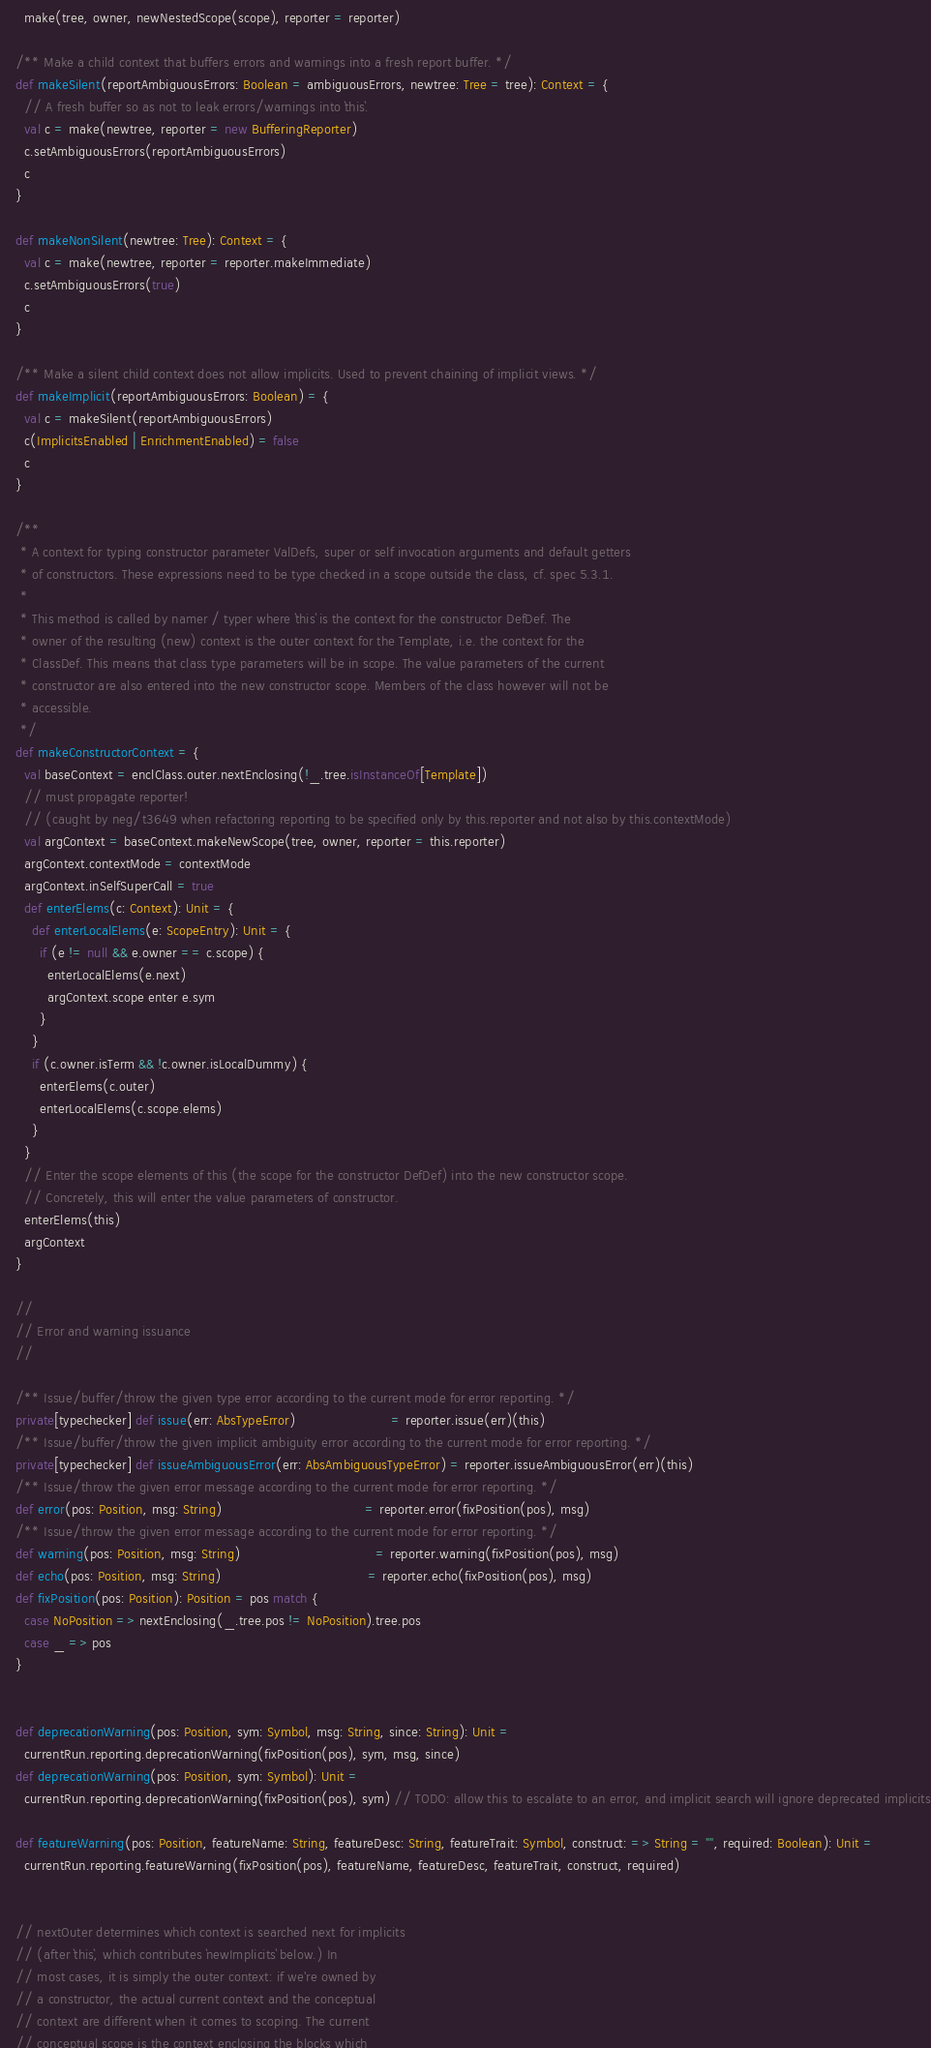<code> <loc_0><loc_0><loc_500><loc_500><_Scala_>      make(tree, owner, newNestedScope(scope), reporter = reporter)

    /** Make a child context that buffers errors and warnings into a fresh report buffer. */
    def makeSilent(reportAmbiguousErrors: Boolean = ambiguousErrors, newtree: Tree = tree): Context = {
      // A fresh buffer so as not to leak errors/warnings into `this`.
      val c = make(newtree, reporter = new BufferingReporter)
      c.setAmbiguousErrors(reportAmbiguousErrors)
      c
    }

    def makeNonSilent(newtree: Tree): Context = {
      val c = make(newtree, reporter = reporter.makeImmediate)
      c.setAmbiguousErrors(true)
      c
    }

    /** Make a silent child context does not allow implicits. Used to prevent chaining of implicit views. */
    def makeImplicit(reportAmbiguousErrors: Boolean) = {
      val c = makeSilent(reportAmbiguousErrors)
      c(ImplicitsEnabled | EnrichmentEnabled) = false
      c
    }

    /**
     * A context for typing constructor parameter ValDefs, super or self invocation arguments and default getters
     * of constructors. These expressions need to be type checked in a scope outside the class, cf. spec 5.3.1.
     *
     * This method is called by namer / typer where `this` is the context for the constructor DefDef. The
     * owner of the resulting (new) context is the outer context for the Template, i.e. the context for the
     * ClassDef. This means that class type parameters will be in scope. The value parameters of the current
     * constructor are also entered into the new constructor scope. Members of the class however will not be
     * accessible.
     */
    def makeConstructorContext = {
      val baseContext = enclClass.outer.nextEnclosing(!_.tree.isInstanceOf[Template])
      // must propagate reporter!
      // (caught by neg/t3649 when refactoring reporting to be specified only by this.reporter and not also by this.contextMode)
      val argContext = baseContext.makeNewScope(tree, owner, reporter = this.reporter)
      argContext.contextMode = contextMode
      argContext.inSelfSuperCall = true
      def enterElems(c: Context): Unit = {
        def enterLocalElems(e: ScopeEntry): Unit = {
          if (e != null && e.owner == c.scope) {
            enterLocalElems(e.next)
            argContext.scope enter e.sym
          }
        }
        if (c.owner.isTerm && !c.owner.isLocalDummy) {
          enterElems(c.outer)
          enterLocalElems(c.scope.elems)
        }
      }
      // Enter the scope elements of this (the scope for the constructor DefDef) into the new constructor scope.
      // Concretely, this will enter the value parameters of constructor.
      enterElems(this)
      argContext
    }

    //
    // Error and warning issuance
    //

    /** Issue/buffer/throw the given type error according to the current mode for error reporting. */
    private[typechecker] def issue(err: AbsTypeError)                        = reporter.issue(err)(this)
    /** Issue/buffer/throw the given implicit ambiguity error according to the current mode for error reporting. */
    private[typechecker] def issueAmbiguousError(err: AbsAmbiguousTypeError) = reporter.issueAmbiguousError(err)(this)
    /** Issue/throw the given error message according to the current mode for error reporting. */
    def error(pos: Position, msg: String)                                    = reporter.error(fixPosition(pos), msg)
    /** Issue/throw the given error message according to the current mode for error reporting. */
    def warning(pos: Position, msg: String)                                  = reporter.warning(fixPosition(pos), msg)
    def echo(pos: Position, msg: String)                                     = reporter.echo(fixPosition(pos), msg)
    def fixPosition(pos: Position): Position = pos match {
      case NoPosition => nextEnclosing(_.tree.pos != NoPosition).tree.pos
      case _ => pos
    }


    def deprecationWarning(pos: Position, sym: Symbol, msg: String, since: String): Unit =
      currentRun.reporting.deprecationWarning(fixPosition(pos), sym, msg, since)
    def deprecationWarning(pos: Position, sym: Symbol): Unit =
      currentRun.reporting.deprecationWarning(fixPosition(pos), sym) // TODO: allow this to escalate to an error, and implicit search will ignore deprecated implicits

    def featureWarning(pos: Position, featureName: String, featureDesc: String, featureTrait: Symbol, construct: => String = "", required: Boolean): Unit =
      currentRun.reporting.featureWarning(fixPosition(pos), featureName, featureDesc, featureTrait, construct, required)


    // nextOuter determines which context is searched next for implicits
    // (after `this`, which contributes `newImplicits` below.) In
    // most cases, it is simply the outer context: if we're owned by
    // a constructor, the actual current context and the conceptual
    // context are different when it comes to scoping. The current
    // conceptual scope is the context enclosing the blocks which</code> 